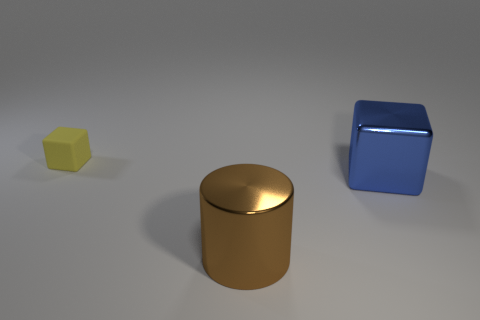Subtract all cylinders. How many objects are left? 2 Subtract all purple cylinders. Subtract all brown balls. How many cylinders are left? 1 Subtract all red balls. How many yellow blocks are left? 1 Subtract all small blue rubber balls. Subtract all small objects. How many objects are left? 2 Add 2 matte objects. How many matte objects are left? 3 Add 1 tiny purple metal things. How many tiny purple metal things exist? 1 Add 1 tiny green shiny objects. How many objects exist? 4 Subtract 0 purple blocks. How many objects are left? 3 